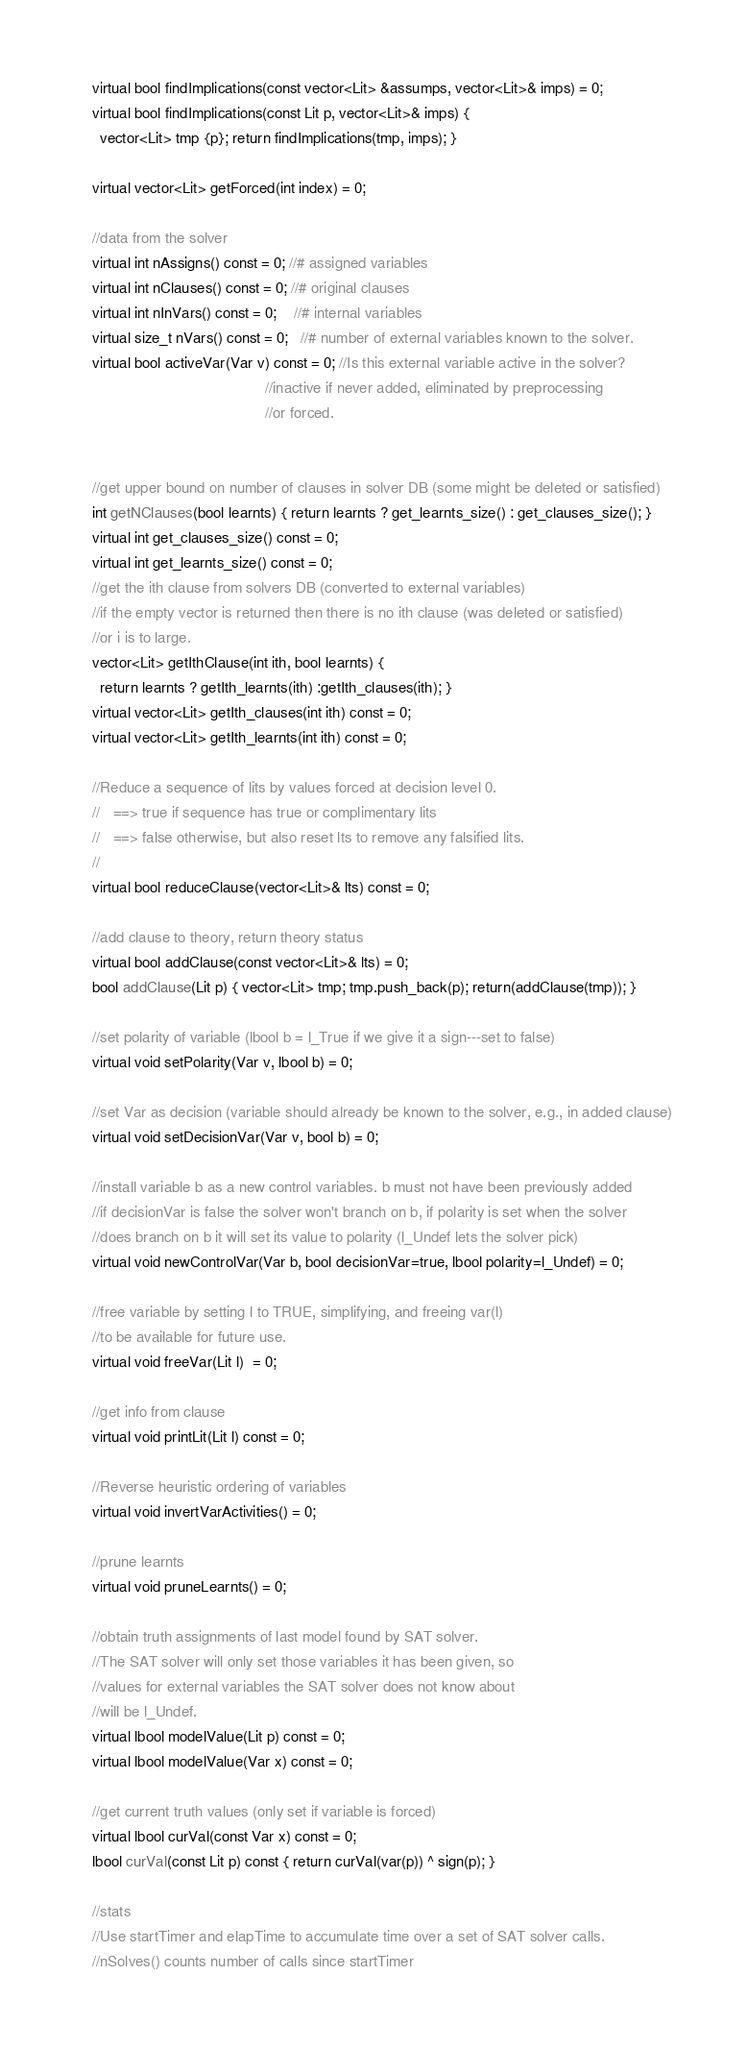<code> <loc_0><loc_0><loc_500><loc_500><_C_>
    virtual bool findImplications(const vector<Lit> &assumps, vector<Lit>& imps) = 0;
    virtual bool findImplications(const Lit p, vector<Lit>& imps) {
      vector<Lit> tmp {p}; return findImplications(tmp, imps); }

    virtual vector<Lit> getForced(int index) = 0; 

    //data from the solver
    virtual int nAssigns() const = 0; //# assigned variables
    virtual int nClauses() const = 0; //# original clauses
    virtual int nInVars() const = 0;    //# internal variables
    virtual size_t nVars() const = 0;   //# number of external variables known to the solver.
    virtual bool activeVar(Var v) const = 0; //Is this external variable active in the solver? 
                                             //inactive if never added, eliminated by preprocessing
                                             //or forced.


    //get upper bound on number of clauses in solver DB (some might be deleted or satisfied)
    int getNClauses(bool learnts) { return learnts ? get_learnts_size() : get_clauses_size(); }
    virtual int get_clauses_size() const = 0;
    virtual int get_learnts_size() const = 0;
    //get the ith clause from solvers DB (converted to external variables)
    //if the empty vector is returned then there is no ith clause (was deleted or satisfied)
    //or i is to large.
    vector<Lit> getIthClause(int ith, bool learnts) { 
      return learnts ? getIth_learnts(ith) :getIth_clauses(ith); }
    virtual vector<Lit> getIth_clauses(int ith) const = 0;
    virtual vector<Lit> getIth_learnts(int ith) const = 0;
    
    //Reduce a sequence of lits by values forced at decision level 0.
    //   ==> true if sequence has true or complimentary lits
    //   ==> false otherwise, but also reset lts to remove any falsified lits.
    //
    virtual bool reduceClause(vector<Lit>& lts) const = 0;
    
    //add clause to theory, return theory status
    virtual bool addClause(const vector<Lit>& lts) = 0;
    bool addClause(Lit p) { vector<Lit> tmp; tmp.push_back(p); return(addClause(tmp)); }

    //set polarity of variable (lbool b = l_True if we give it a sign---set to false)
    virtual void setPolarity(Var v, lbool b) = 0;

    //set Var as decision (variable should already be known to the solver, e.g., in added clause)
    virtual void setDecisionVar(Var v, bool b) = 0;

    //install variable b as a new control variables. b must not have been previously added
    //if decisionVar is false the solver won't branch on b, if polarity is set when the solver
    //does branch on b it will set its value to polarity (l_Undef lets the solver pick)
    virtual void newControlVar(Var b, bool decisionVar=true, lbool polarity=l_Undef) = 0;

    //free variable by setting l to TRUE, simplifying, and freeing var(l)
    //to be available for future use.
    virtual void freeVar(Lit l)  = 0;

    //get info from clause
    virtual void printLit(Lit l) const = 0;
    
    //Reverse heuristic ordering of variables
    virtual void invertVarActivities() = 0;
    
    //prune learnts 
    virtual void pruneLearnts() = 0;
    
    //obtain truth assignments of last model found by SAT solver.
    //The SAT solver will only set those variables it has been given, so
    //values for external variables the SAT solver does not know about 
    //will be l_Undef.
    virtual lbool modelValue(Lit p) const = 0;
    virtual lbool modelValue(Var x) const = 0;
    
    //get current truth values (only set if variable is forced)
    virtual lbool curVal(const Var x) const = 0;
    lbool curVal(const Lit p) const { return curVal(var(p)) ^ sign(p); }
    
    //stats
    //Use startTimer and elapTime to accumulate time over a set of SAT solver calls.
    //nSolves() counts number of calls since startTimer</code> 